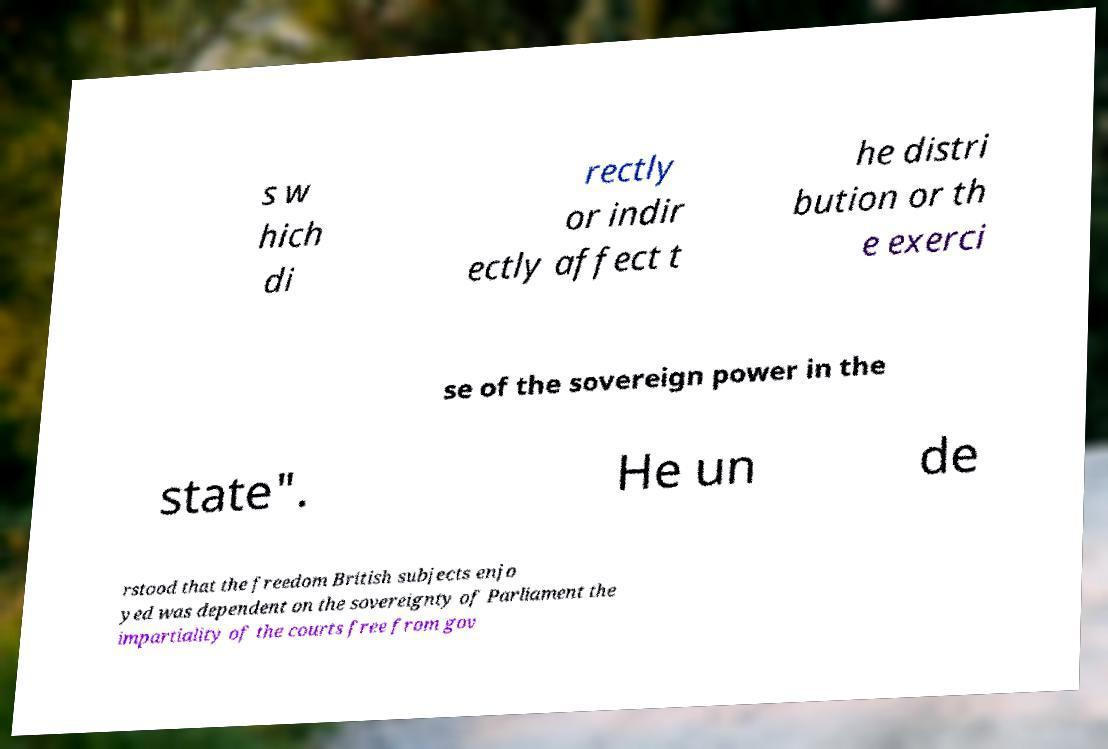For documentation purposes, I need the text within this image transcribed. Could you provide that? s w hich di rectly or indir ectly affect t he distri bution or th e exerci se of the sovereign power in the state". He un de rstood that the freedom British subjects enjo yed was dependent on the sovereignty of Parliament the impartiality of the courts free from gov 